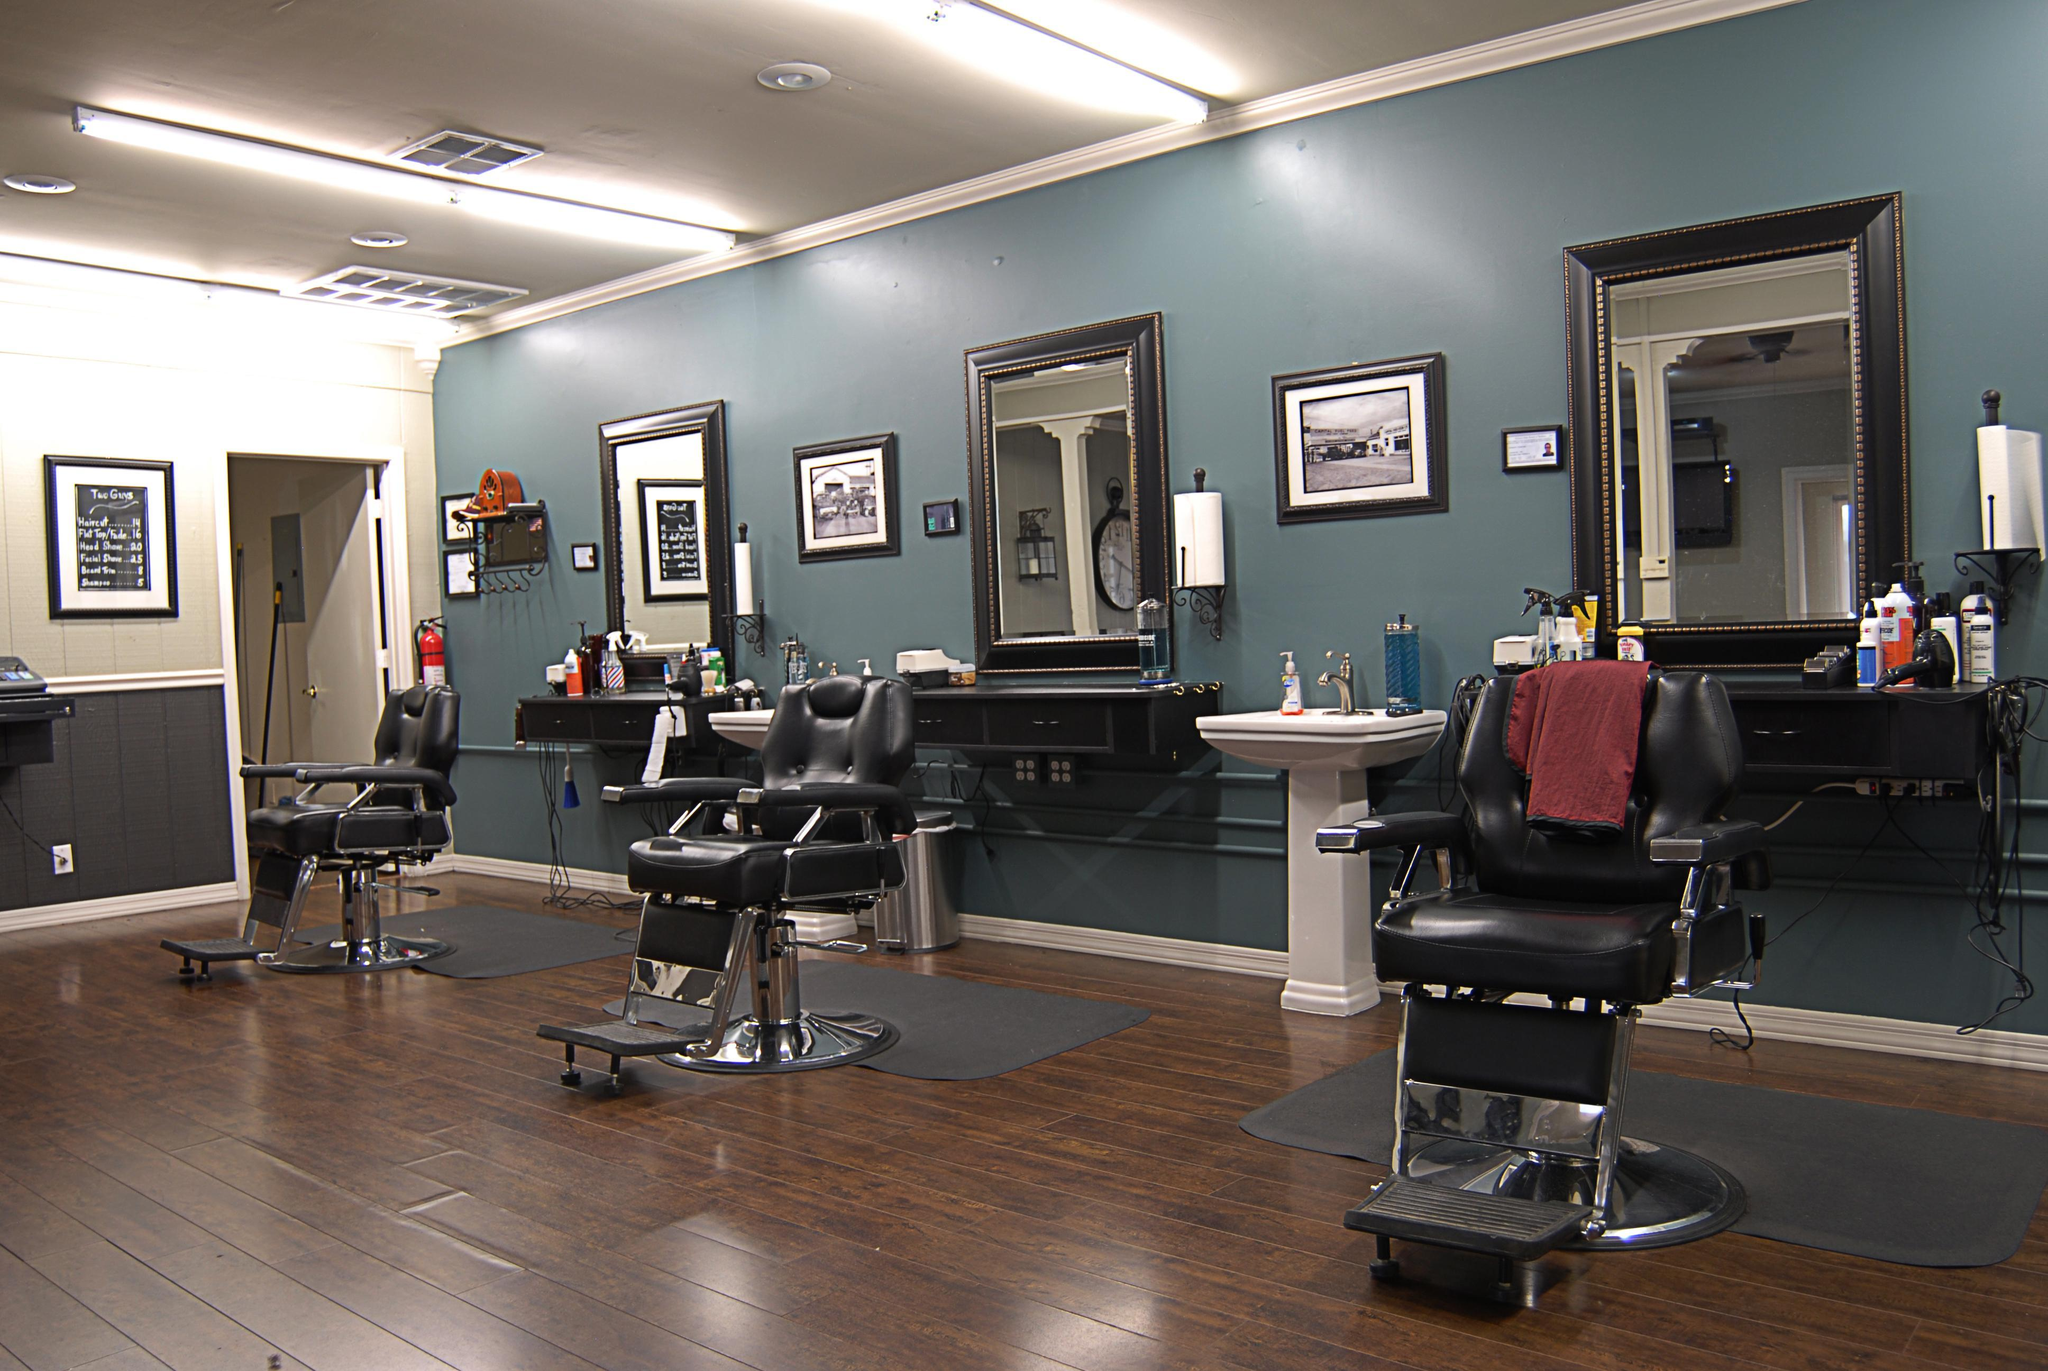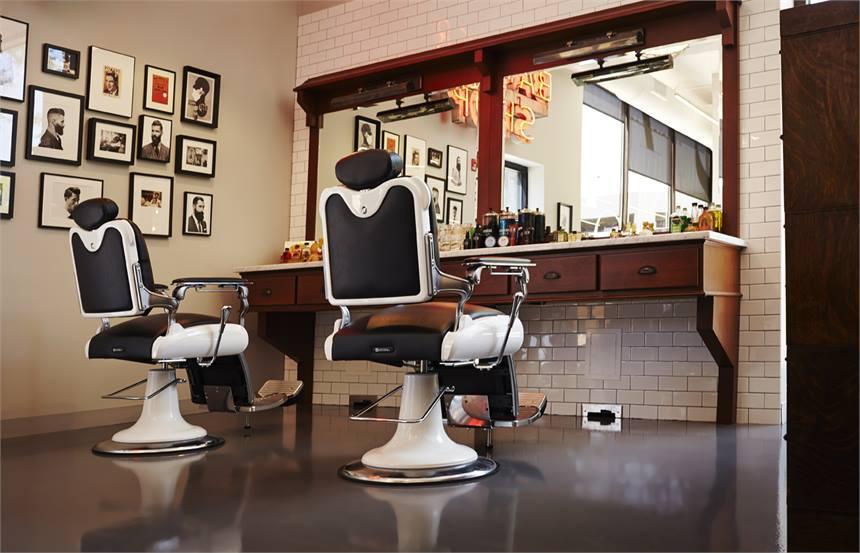The first image is the image on the left, the second image is the image on the right. Evaluate the accuracy of this statement regarding the images: "There are more than eleven frames on the wall in one of the images.". Is it true? Answer yes or no. Yes. 